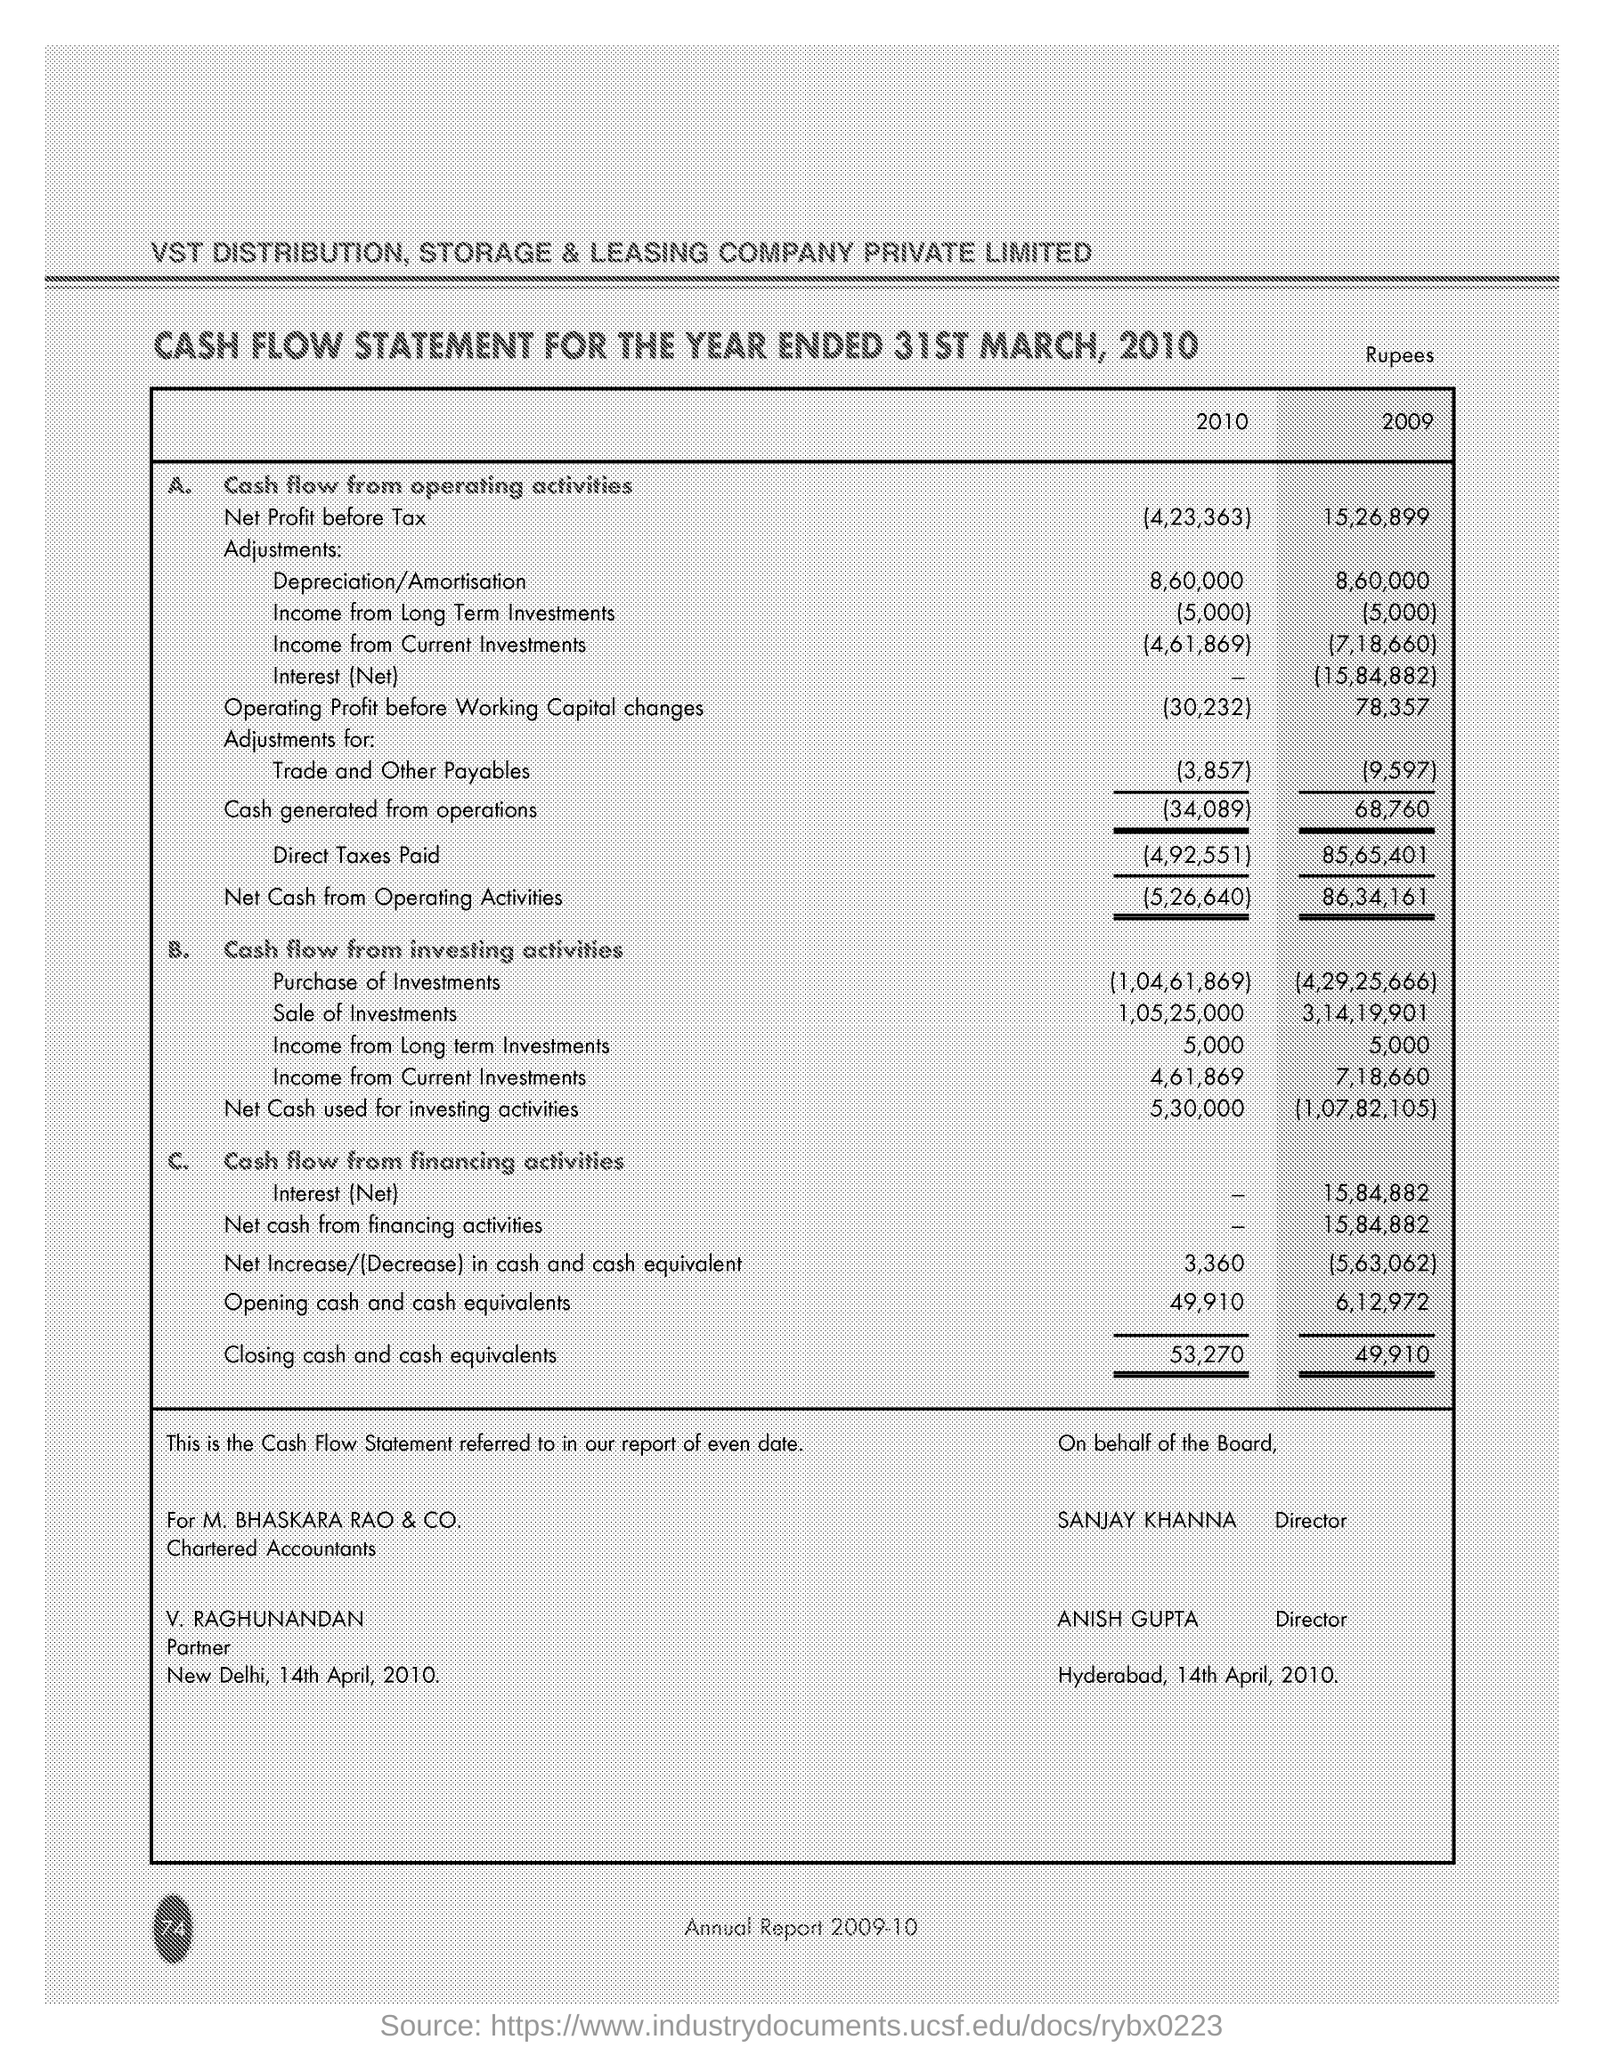Mention a couple of crucial points in this snapshot. V. Raghunandan is the partner. The company name is VST Distribution. The closing cash and cash equivalents in 2010 were approximately $53,270. The net profit before tax in 2010 was 4,23,363. The total amount of Direct Taxes paid in 2010 was 4,92,551. 